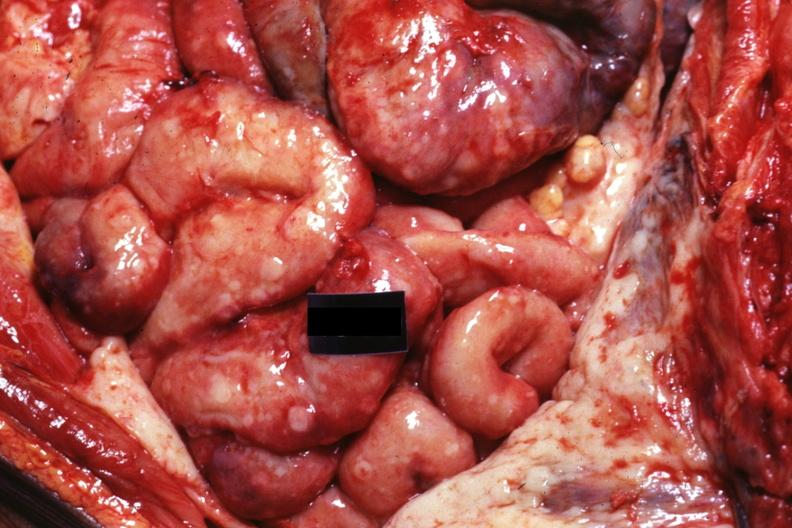where is this area in the body?
Answer the question using a single word or phrase. Abdomen 